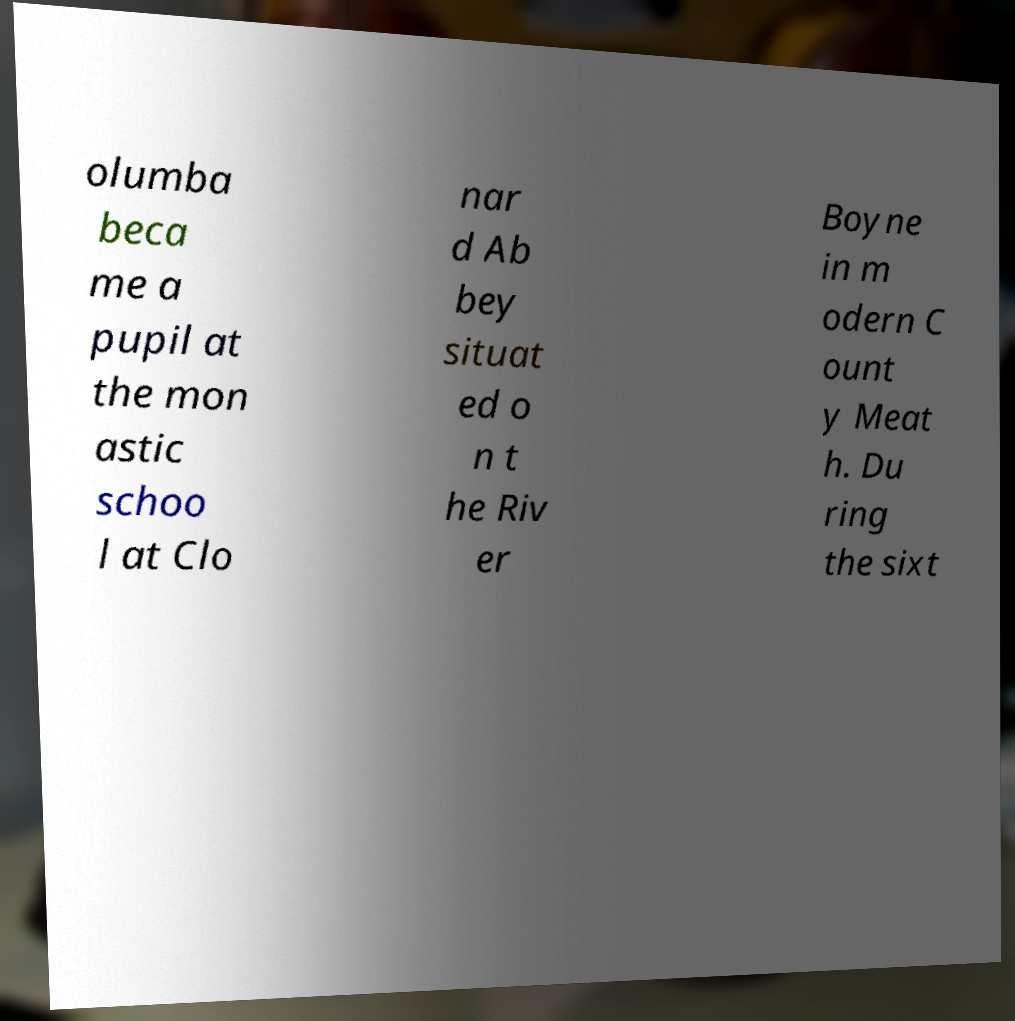Could you extract and type out the text from this image? olumba beca me a pupil at the mon astic schoo l at Clo nar d Ab bey situat ed o n t he Riv er Boyne in m odern C ount y Meat h. Du ring the sixt 